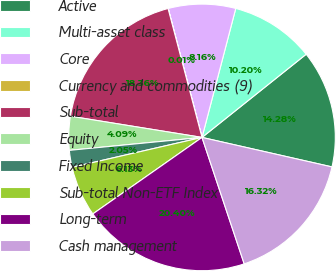Convert chart. <chart><loc_0><loc_0><loc_500><loc_500><pie_chart><fcel>Active<fcel>Multi-asset class<fcel>Core<fcel>Currency and commodities (9)<fcel>Sub-total<fcel>Equity<fcel>Fixed Income<fcel>Sub-total Non-ETF Index<fcel>Long-term<fcel>Cash management<nl><fcel>14.28%<fcel>10.2%<fcel>8.16%<fcel>0.01%<fcel>18.36%<fcel>4.09%<fcel>2.05%<fcel>6.13%<fcel>20.4%<fcel>16.32%<nl></chart> 